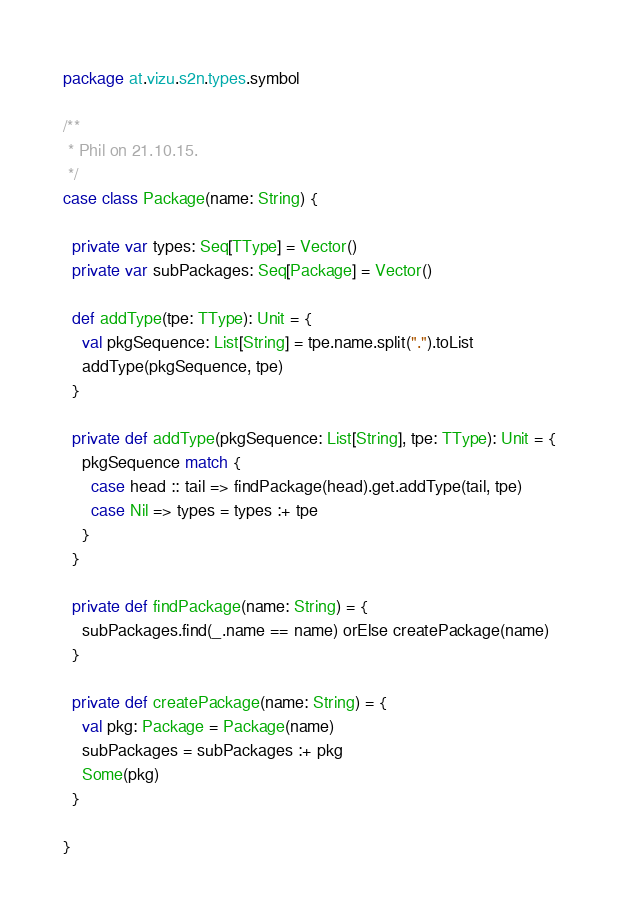Convert code to text. <code><loc_0><loc_0><loc_500><loc_500><_Scala_>package at.vizu.s2n.types.symbol

/**
 * Phil on 21.10.15.
 */
case class Package(name: String) {

  private var types: Seq[TType] = Vector()
  private var subPackages: Seq[Package] = Vector()

  def addType(tpe: TType): Unit = {
    val pkgSequence: List[String] = tpe.name.split(".").toList
    addType(pkgSequence, tpe)
  }

  private def addType(pkgSequence: List[String], tpe: TType): Unit = {
    pkgSequence match {
      case head :: tail => findPackage(head).get.addType(tail, tpe)
      case Nil => types = types :+ tpe
    }
  }

  private def findPackage(name: String) = {
    subPackages.find(_.name == name) orElse createPackage(name)
  }

  private def createPackage(name: String) = {
    val pkg: Package = Package(name)
    subPackages = subPackages :+ pkg
    Some(pkg)
  }

}
</code> 